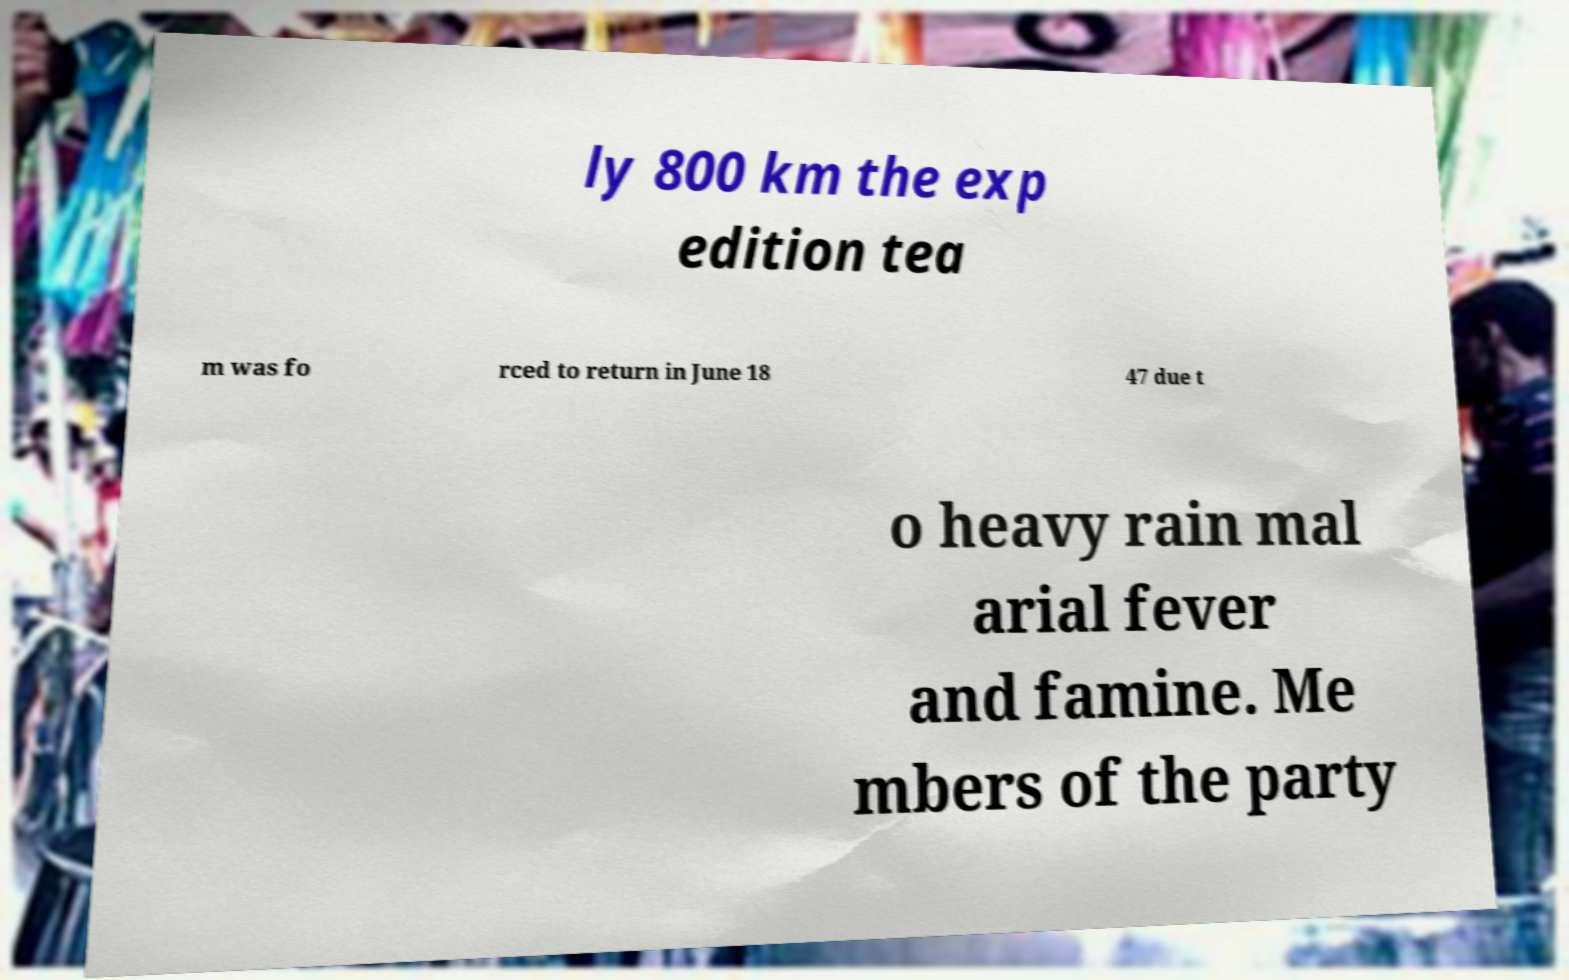What messages or text are displayed in this image? I need them in a readable, typed format. ly 800 km the exp edition tea m was fo rced to return in June 18 47 due t o heavy rain mal arial fever and famine. Me mbers of the party 